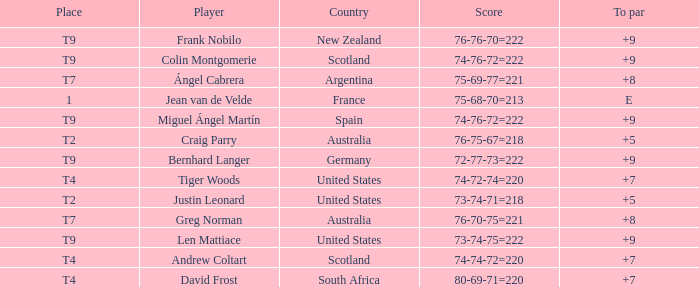Player Craig Parry of Australia is in what place number? T2. 